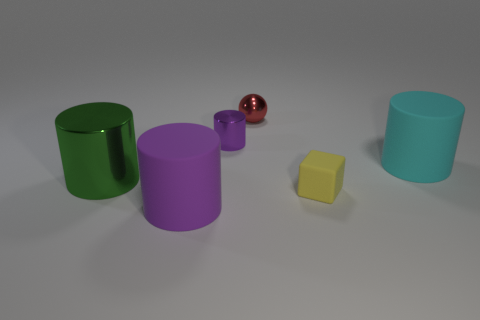Add 4 small yellow rubber things. How many objects exist? 10 Subtract all large green metallic cylinders. How many cylinders are left? 3 Subtract 3 cylinders. How many cylinders are left? 1 Subtract all green cylinders. How many cylinders are left? 3 Subtract all balls. How many objects are left? 5 Subtract all big purple cylinders. Subtract all small purple shiny things. How many objects are left? 4 Add 3 small shiny spheres. How many small shiny spheres are left? 4 Add 6 tiny yellow things. How many tiny yellow things exist? 7 Subtract 0 blue balls. How many objects are left? 6 Subtract all blue cylinders. Subtract all red cubes. How many cylinders are left? 4 